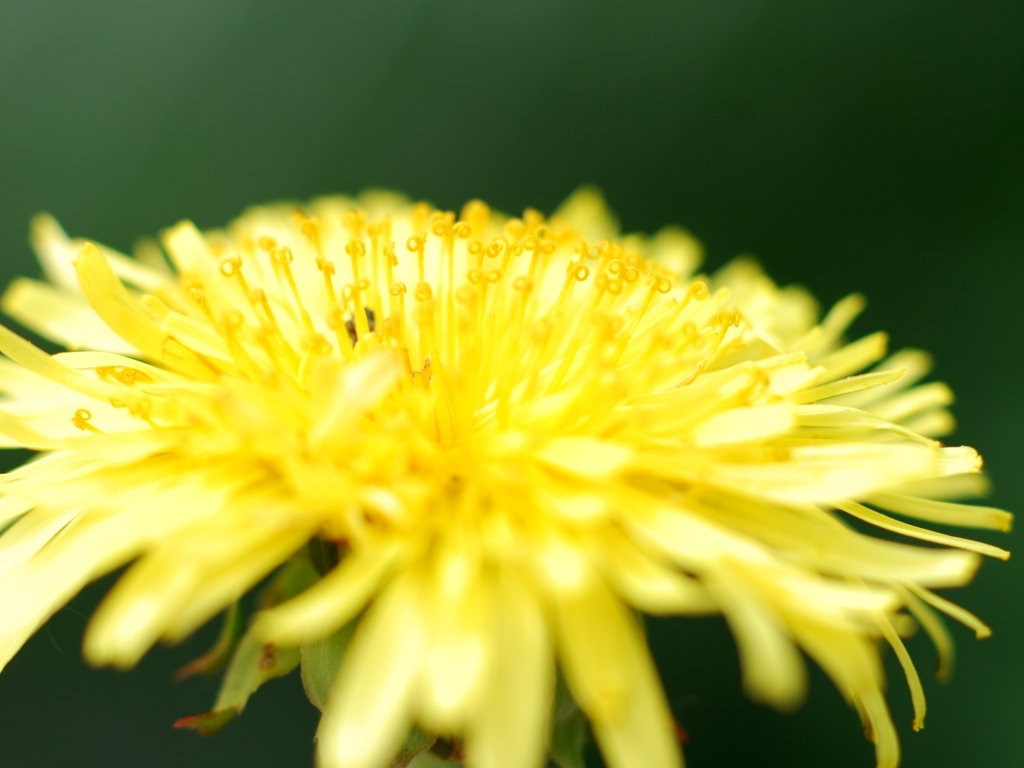Is the overall lighting of the image sufficient?
 Yes 